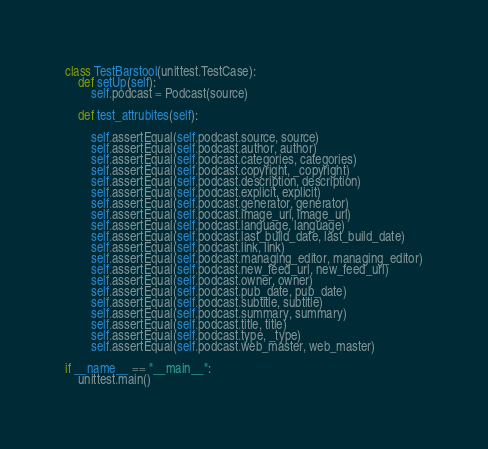Convert code to text. <code><loc_0><loc_0><loc_500><loc_500><_Python_>
class TestBarstool(unittest.TestCase):
    def setUp(self):
        self.podcast = Podcast(source)

    def test_attrubites(self):

        self.assertEqual(self.podcast.source, source)
        self.assertEqual(self.podcast.author, author)
        self.assertEqual(self.podcast.categories, categories)
        self.assertEqual(self.podcast.copyright, _copyright)
        self.assertEqual(self.podcast.description, description)
        self.assertEqual(self.podcast.explicit, explicit)
        self.assertEqual(self.podcast.generator, generator)
        self.assertEqual(self.podcast.image_url, image_url)
        self.assertEqual(self.podcast.language, language)
        self.assertEqual(self.podcast.last_build_date, last_build_date)
        self.assertEqual(self.podcast.link, link)
        self.assertEqual(self.podcast.managing_editor, managing_editor)
        self.assertEqual(self.podcast.new_feed_url, new_feed_url)
        self.assertEqual(self.podcast.owner, owner)
        self.assertEqual(self.podcast.pub_date, pub_date)
        self.assertEqual(self.podcast.subtitle, subtitle)
        self.assertEqual(self.podcast.summary, summary)
        self.assertEqual(self.podcast.title, title)
        self.assertEqual(self.podcast.type, _type)
        self.assertEqual(self.podcast.web_master, web_master)

if __name__ == "__main__":
    unittest.main()
</code> 